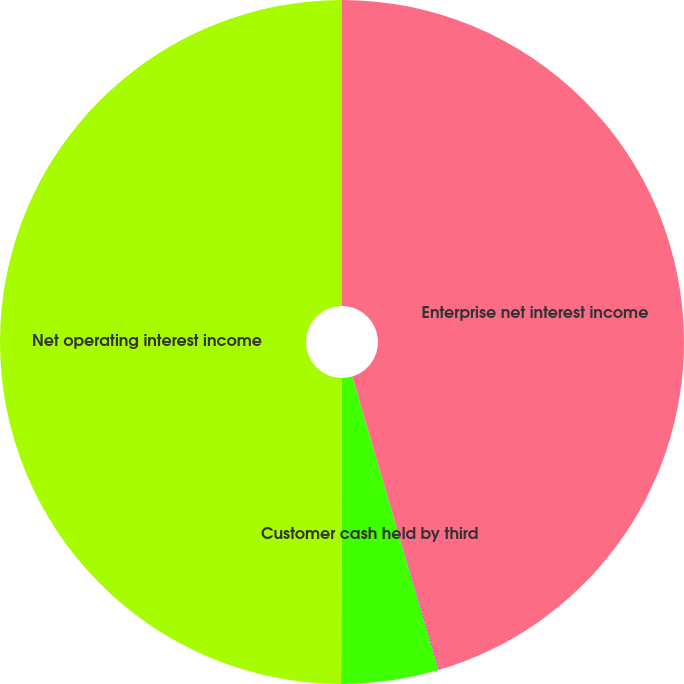Convert chart. <chart><loc_0><loc_0><loc_500><loc_500><pie_chart><fcel>Enterprise net interest income<fcel>Taxable equivalent interest<fcel>Customer cash held by third<fcel>Net operating interest income<nl><fcel>45.4%<fcel>0.04%<fcel>4.6%<fcel>49.96%<nl></chart> 